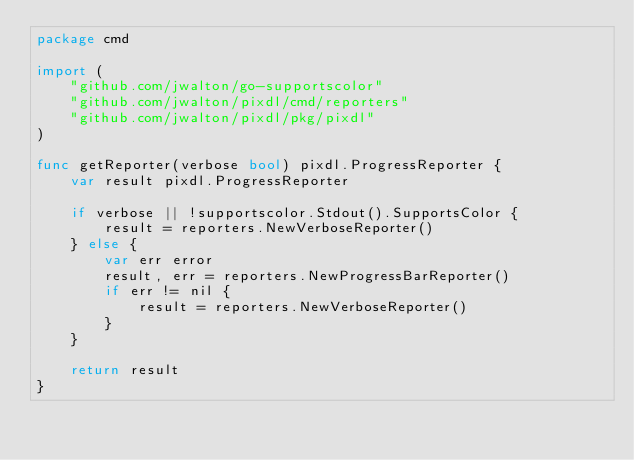<code> <loc_0><loc_0><loc_500><loc_500><_Go_>package cmd

import (
	"github.com/jwalton/go-supportscolor"
	"github.com/jwalton/pixdl/cmd/reporters"
	"github.com/jwalton/pixdl/pkg/pixdl"
)

func getReporter(verbose bool) pixdl.ProgressReporter {
	var result pixdl.ProgressReporter

	if verbose || !supportscolor.Stdout().SupportsColor {
		result = reporters.NewVerboseReporter()
	} else {
		var err error
		result, err = reporters.NewProgressBarReporter()
		if err != nil {
			result = reporters.NewVerboseReporter()
		}
	}

	return result
}
</code> 